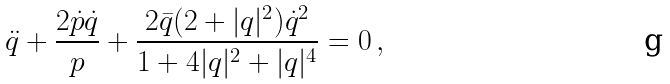Convert formula to latex. <formula><loc_0><loc_0><loc_500><loc_500>\ddot { q } + \frac { 2 \dot { p } \dot { q } } { p } + \frac { 2 \bar { q } ( 2 + | q | ^ { 2 } ) \dot { q } ^ { 2 } } { 1 + 4 | q | ^ { 2 } + | q | ^ { 4 } } = 0 \, ,</formula> 